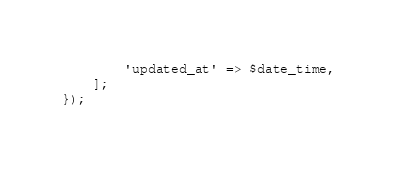<code> <loc_0><loc_0><loc_500><loc_500><_PHP_>        'updated_at' => $date_time,
    ];
});
</code> 